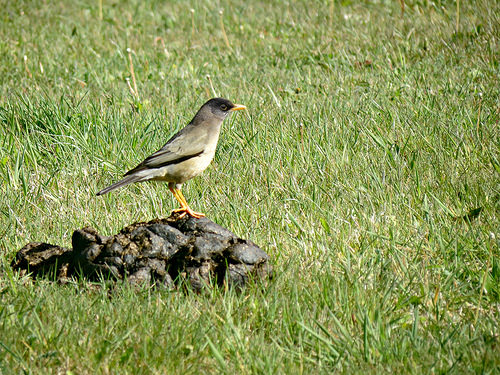<image>
Is the cow patty under the bird? Yes. The cow patty is positioned underneath the bird, with the bird above it in the vertical space. 